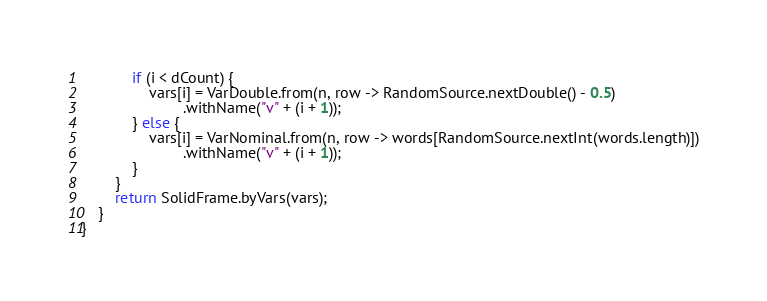<code> <loc_0><loc_0><loc_500><loc_500><_Java_>            if (i < dCount) {
                vars[i] = VarDouble.from(n, row -> RandomSource.nextDouble() - 0.5)
                        .withName("v" + (i + 1));
            } else {
                vars[i] = VarNominal.from(n, row -> words[RandomSource.nextInt(words.length)])
                        .withName("v" + (i + 1));
            }
        }
        return SolidFrame.byVars(vars);
    }
}
</code> 